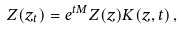<formula> <loc_0><loc_0><loc_500><loc_500>Z ( z _ { t } ) = e ^ { t M } Z ( z ) K ( z , t ) \, ,</formula> 